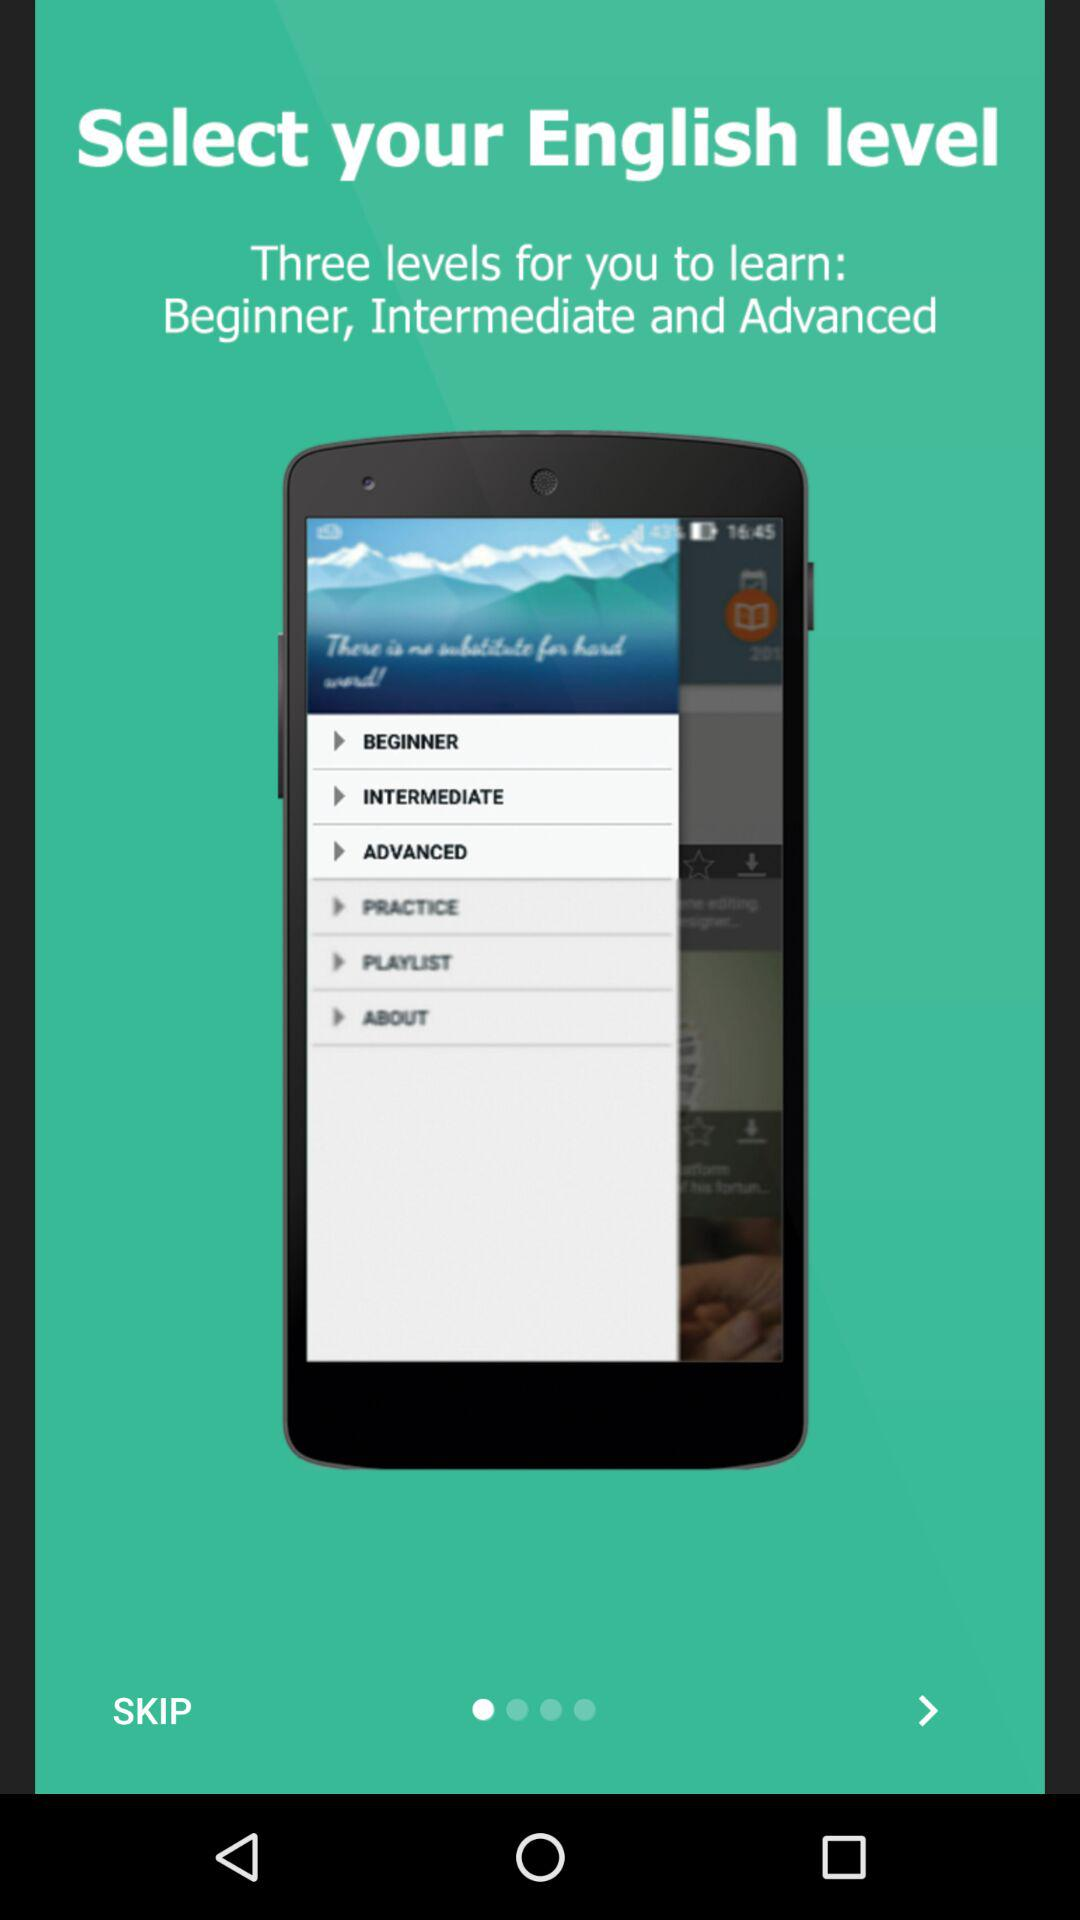How many levels are available?
Answer the question using a single word or phrase. 3 